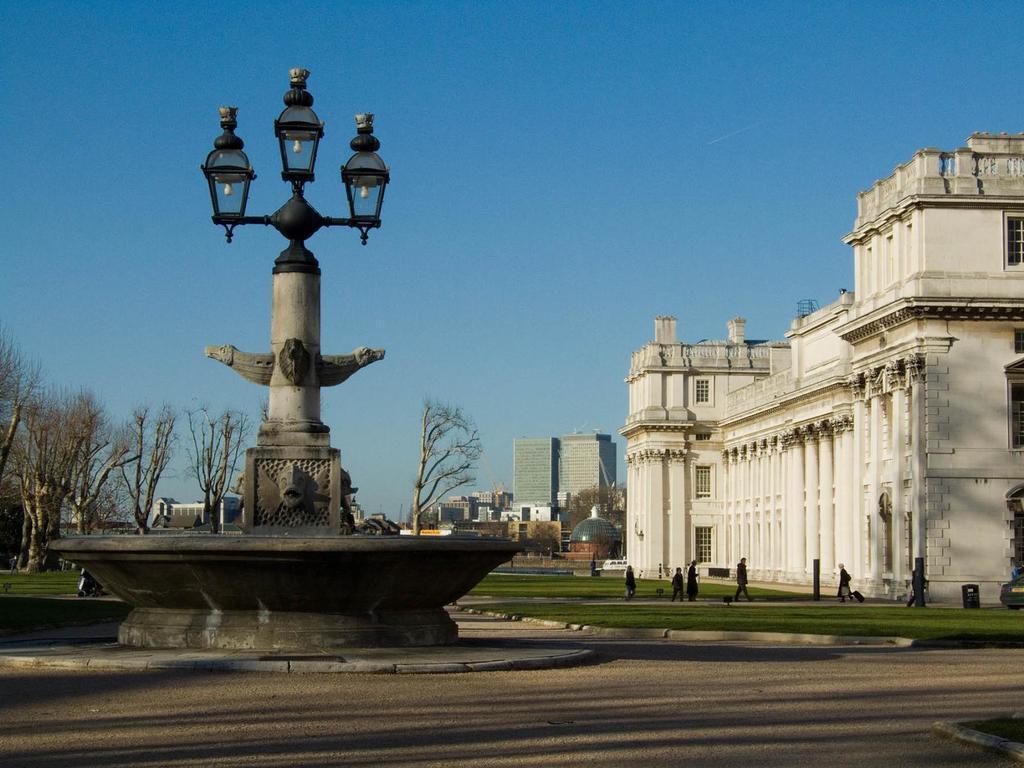In one or two sentences, can you explain what this image depicts? On the left side there is a monument with 3 different structures on it. At the back side there are trees, on the right side there is a monument in white color. At the top it is the blue color sky. 